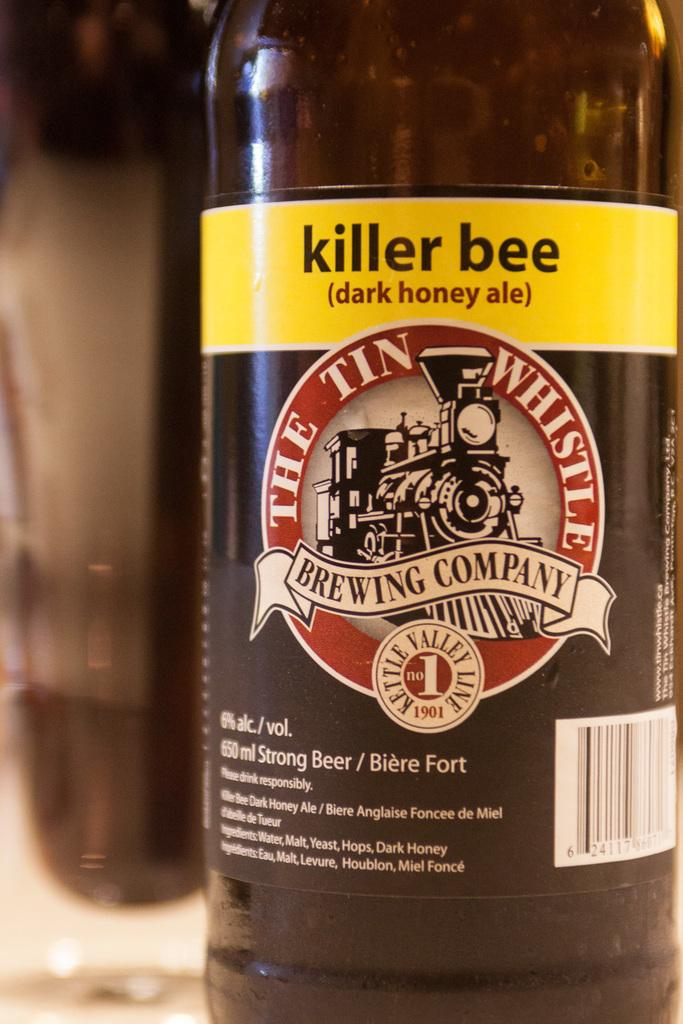<image>
Give a short and clear explanation of the subsequent image. A bottle of Killer Bee, dark honey ale is half empty. 